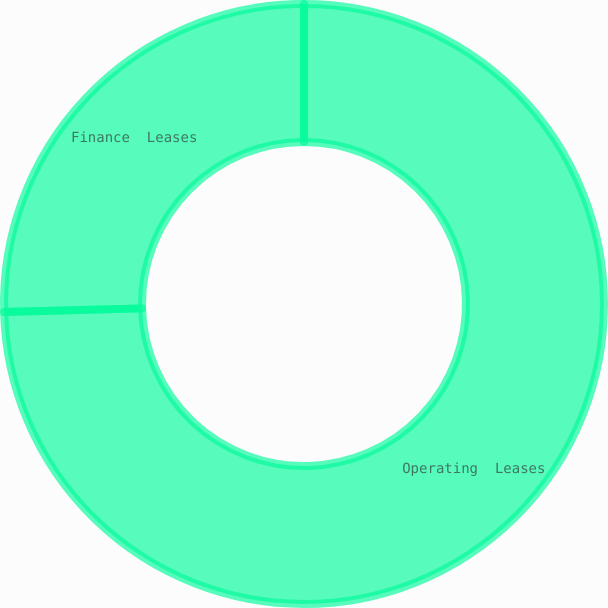<chart> <loc_0><loc_0><loc_500><loc_500><pie_chart><fcel>Operating  Leases<fcel>Finance  Leases<nl><fcel>74.57%<fcel>25.43%<nl></chart> 